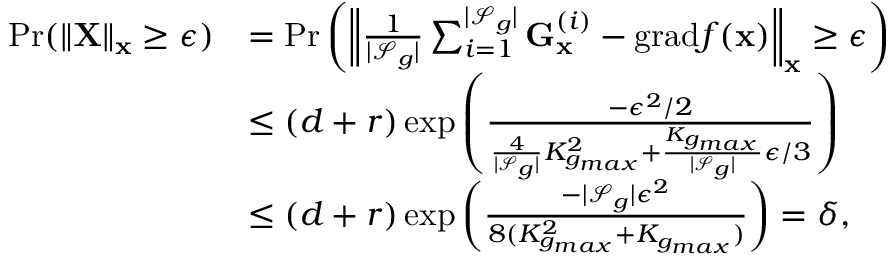<formula> <loc_0><loc_0><loc_500><loc_500>\begin{array} { r l } { P r ( \| X \| _ { x } \geq \epsilon ) } & { = P r \left ( \left \| \frac { 1 } { | \mathcal { S } _ { g } | } \sum _ { i = 1 } ^ { | \mathcal { S } _ { g } | } G _ { x } ^ { ( i ) } - g r a d f ( x ) \right \| _ { x } \geq \epsilon \right ) } \\ & { \leq ( d + r ) \exp \left ( \frac { - \epsilon ^ { 2 } / 2 } { \frac { 4 } { | \mathcal { S } _ { g } | } K _ { g _ { \max } } ^ { 2 } + \frac { K _ { g _ { \max } } } { | \mathcal { S } _ { g } | } \epsilon / 3 } \right ) } \\ & { \leq ( d + r ) \exp \left ( \frac { - | \mathcal { S } _ { g } | \epsilon ^ { 2 } } { 8 ( K _ { g _ { \max } } ^ { 2 } + K _ { g _ { \max } } ) } \right ) = \delta , } \end{array}</formula> 